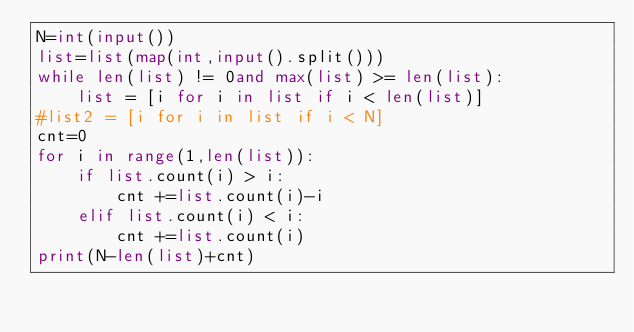Convert code to text. <code><loc_0><loc_0><loc_500><loc_500><_Python_>N=int(input())
list=list(map(int,input().split()))
while len(list) != 0and max(list) >= len(list):
    list = [i for i in list if i < len(list)]
#list2 = [i for i in list if i < N]
cnt=0
for i in range(1,len(list)):
    if list.count(i) > i:
        cnt +=list.count(i)-i
    elif list.count(i) < i:
        cnt +=list.count(i)
print(N-len(list)+cnt)
</code> 